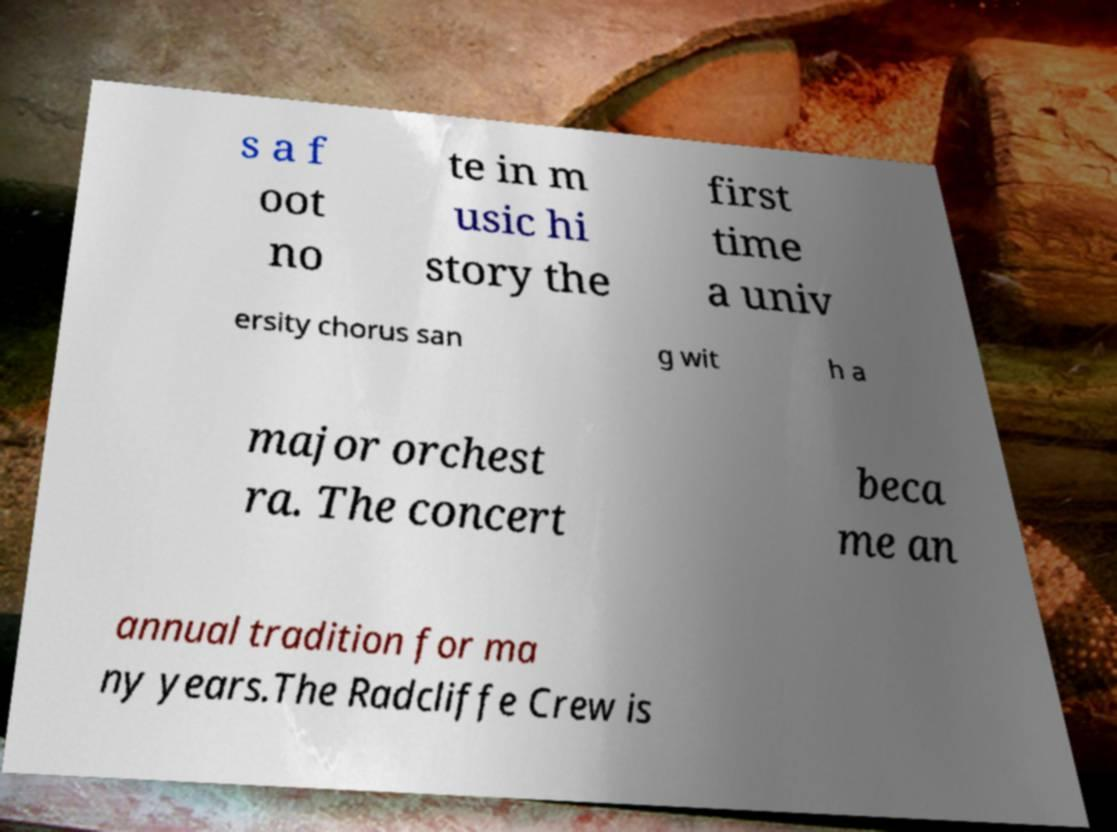For documentation purposes, I need the text within this image transcribed. Could you provide that? s a f oot no te in m usic hi story the first time a univ ersity chorus san g wit h a major orchest ra. The concert beca me an annual tradition for ma ny years.The Radcliffe Crew is 